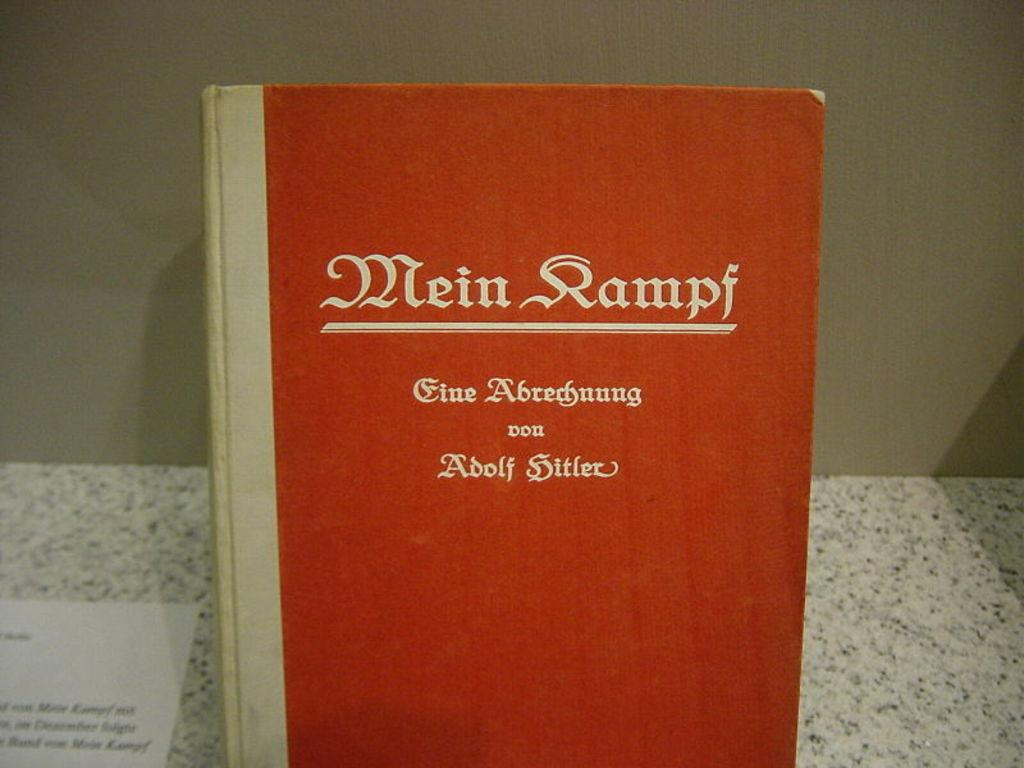<image>
Offer a succinct explanation of the picture presented. A copy of Mein Kampf by Adolf Hitler. 